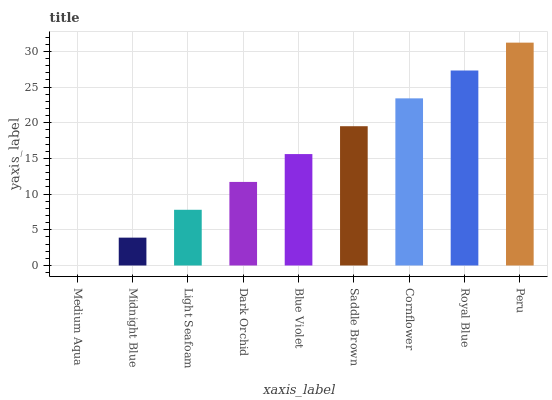Is Midnight Blue the minimum?
Answer yes or no. No. Is Midnight Blue the maximum?
Answer yes or no. No. Is Midnight Blue greater than Medium Aqua?
Answer yes or no. Yes. Is Medium Aqua less than Midnight Blue?
Answer yes or no. Yes. Is Medium Aqua greater than Midnight Blue?
Answer yes or no. No. Is Midnight Blue less than Medium Aqua?
Answer yes or no. No. Is Blue Violet the high median?
Answer yes or no. Yes. Is Blue Violet the low median?
Answer yes or no. Yes. Is Saddle Brown the high median?
Answer yes or no. No. Is Medium Aqua the low median?
Answer yes or no. No. 